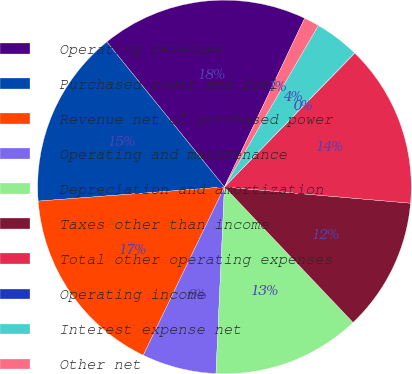Convert chart. <chart><loc_0><loc_0><loc_500><loc_500><pie_chart><fcel>Operating revenues<fcel>Purchased power and fuel<fcel>Revenue net of purchased power<fcel>Operating and maintenance<fcel>Depreciation and amortization<fcel>Taxes other than income<fcel>Total other operating expenses<fcel>Operating income<fcel>Interest expense net<fcel>Other net<nl><fcel>17.91%<fcel>15.36%<fcel>16.64%<fcel>6.43%<fcel>12.81%<fcel>11.53%<fcel>14.09%<fcel>0.04%<fcel>3.87%<fcel>1.32%<nl></chart> 